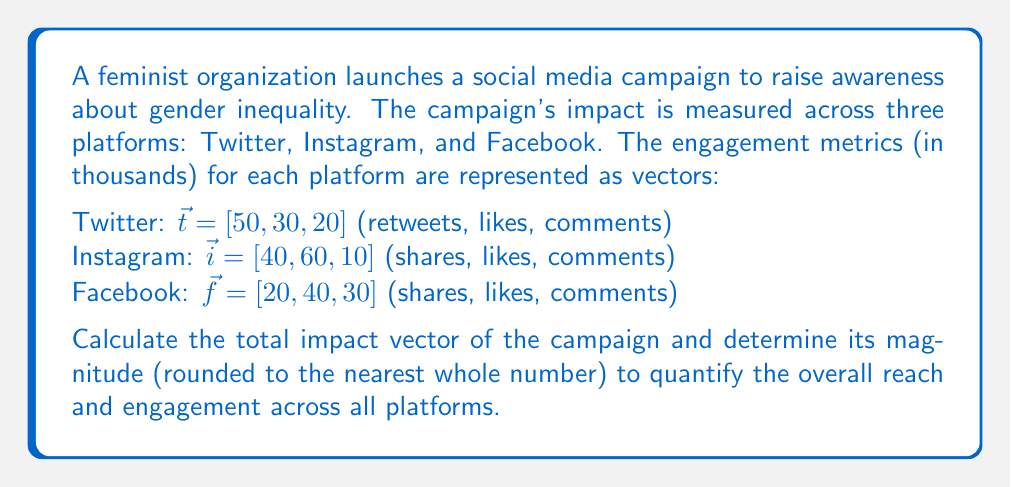Could you help me with this problem? To solve this problem, we'll follow these steps:

1. Add the vectors to get the total impact vector:
   $$\vec{v} = \vec{t} + \vec{i} + \vec{f}$$
   
   $\vec{v} = [50, 30, 20] + [40, 60, 10] + [20, 40, 30]$
   $\vec{v} = [110, 130, 60]$

2. Calculate the magnitude of the total impact vector using the Euclidean norm:
   $$\|\vec{v}\| = \sqrt{v_1^2 + v_2^2 + v_3^2}$$
   
   $\|\vec{v}\| = \sqrt{110^2 + 130^2 + 60^2}$
   $\|\vec{v}\| = \sqrt{12100 + 16900 + 3600}$
   $\|\vec{v}\| = \sqrt{32600}$
   $\|\vec{v}\| \approx 180.55$

3. Round the result to the nearest whole number:
   180.55 rounds to 181

The total impact vector $[110, 130, 60]$ represents the combined engagement across all platforms (shares/retweets, likes, comments). Its magnitude, 181, provides a single metric quantifying the overall reach and engagement of the campaign.
Answer: $[110, 130, 60]$; 181 